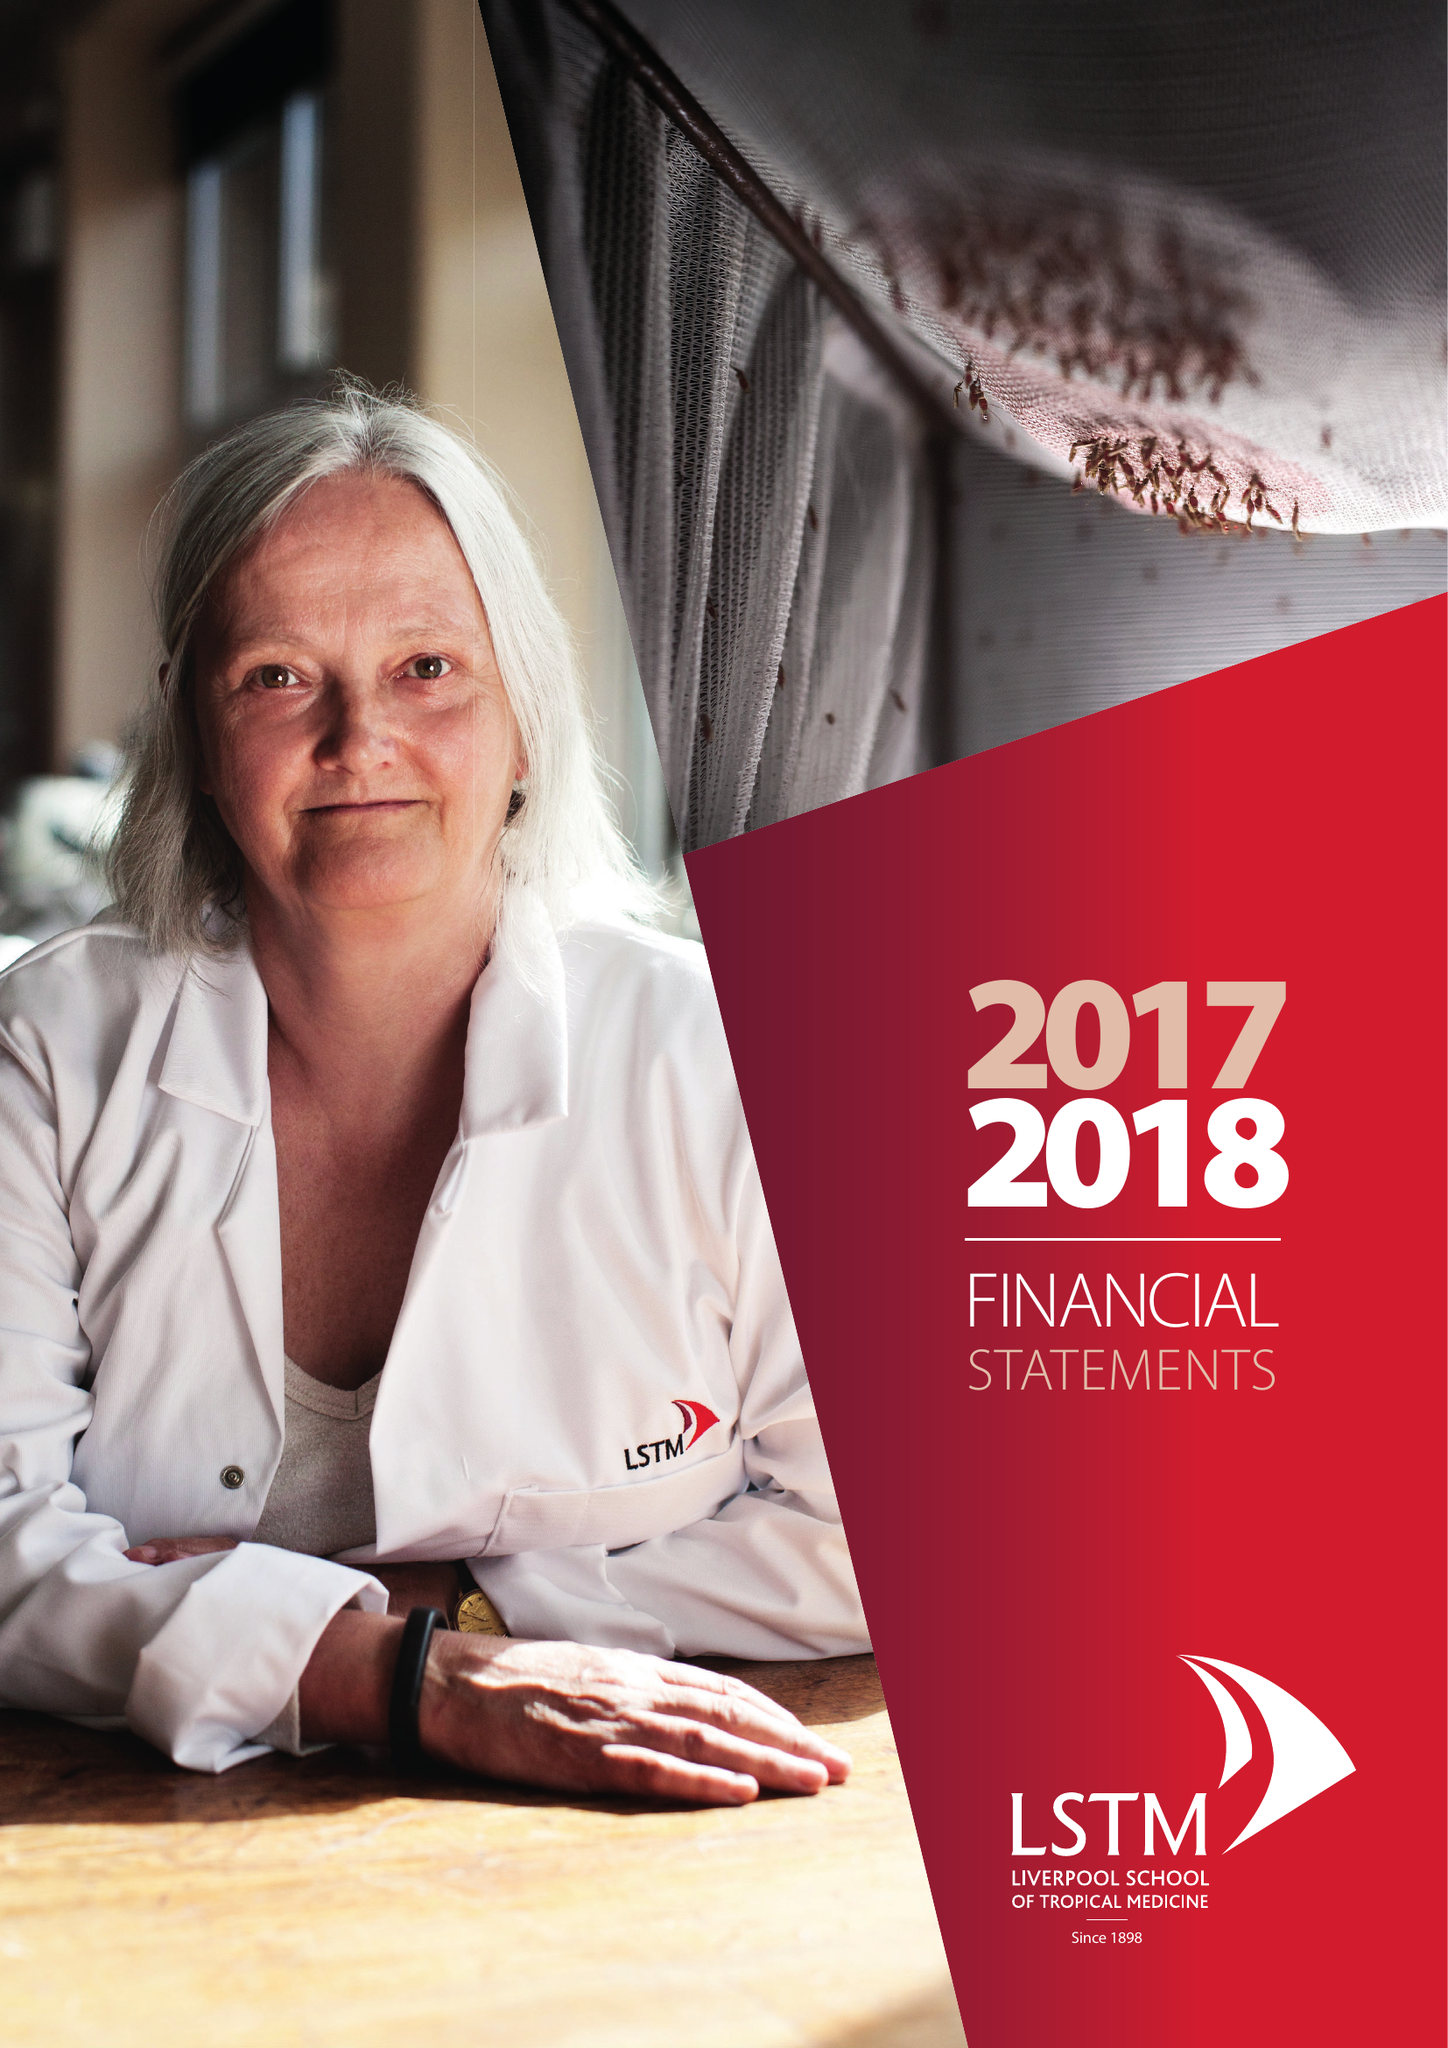What is the value for the address__street_line?
Answer the question using a single word or phrase. PEMBROKE PLACE 